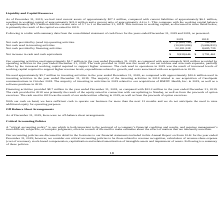From Optimizerx Corporation's financial document, What were the Net cash provided by financing activities in 2018 and 2019 respectively? The document shows two values: 8,685,739 and 22,181,528. From the document: "cash provided by financing activities 22,181,528 8,685,739 Net cash provided by financing activities 22,181,528 8,685,739..." Also, What were the net increases in cash and cash equivalents in 2018 and 2019, respectively? The document shows two values: $3,791,461 and $9,938,646. From the document: "crease in cash and cash equivalents $ 9,938,646 $ 3,791,461 Net increase in cash and cash equivalents $ 9,938,646 $ 3,791,461..." Also, can you calculate: What is the percentage change in the net increase in cash and cash equivalents from 2018 to 2019? To answer this question, I need to perform calculations using the financial data. The calculation is: (9,938,646-3,791,461)/3,791,461 , which equals 162.13 (percentage). This is based on the information: "Net increase in cash and cash equivalents $ 9,938,646 $ 3,791,461 crease in cash and cash equivalents $ 9,938,646 $ 3,791,461..." The key data points involved are: 3,791,461, 9,938,646. Also, can you calculate: What is the average net cash provided by financing activities from 2018 to 2019? To answer this question, I need to perform calculations using the financial data. The calculation is: (22,181,528+8,685,739)/2 , which equals 15433633.5. This is based on the information: "cash provided by financing activities 22,181,528 8,685,739 Net cash provided by financing activities 22,181,528 8,685,739..." The key data points involved are: 22,181,528, 8,685,739. Also, can you calculate: What is the ratio of net cash used in investing activities from 2018 to 2019? To answer this question, I need to perform calculations using the financial data. The calculation is: -5,686,833/-10,582,086 , which equals 0.54. This is based on the information: "Net cash used in investing activities (10,582,086) (5,686,833) t cash used in investing activities (10,582,086) (5,686,833)..." The key data points involved are: 10,582,086, 5,686,833. Also, What were the total current assets and liabilities as of December 31, 2019? The document shows two values: approximately $27.1 million and approximately $6.1 million. From the document: "December 31, 2019, we had total current assets of approximately $27.1 million, compared with current liabilities of approximately $6.1 million, result..." 